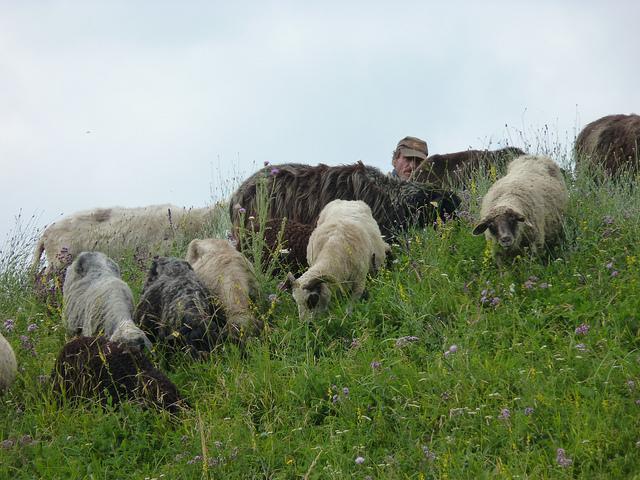How many sheep are in the picture?
Give a very brief answer. 11. How many people on motorcycles are facing this way?
Give a very brief answer. 0. 